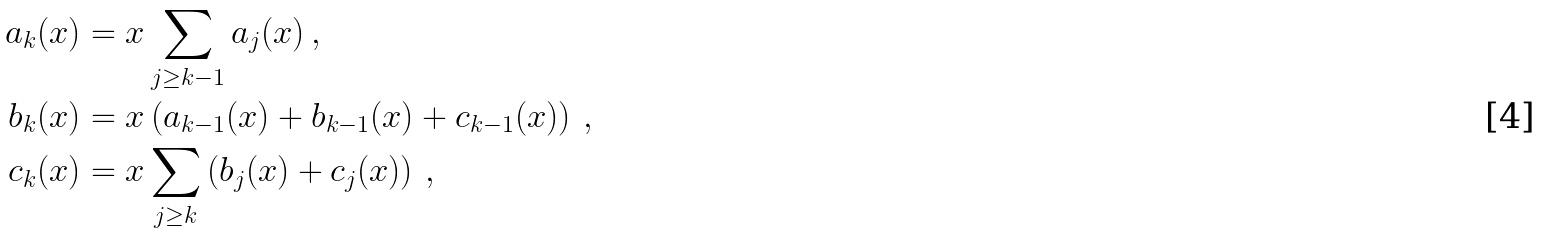<formula> <loc_0><loc_0><loc_500><loc_500>a _ { k } ( x ) & = x \sum _ { j \geq k - 1 } a _ { j } ( x ) \, , \\ b _ { k } ( x ) & = x \left ( a _ { k - 1 } ( x ) + b _ { k - 1 } ( x ) + c _ { k - 1 } ( x ) \right ) \, , \\ c _ { k } ( x ) & = x \sum _ { j \geq k } \left ( b _ { j } ( x ) + c _ { j } ( x ) \right ) \, ,</formula> 